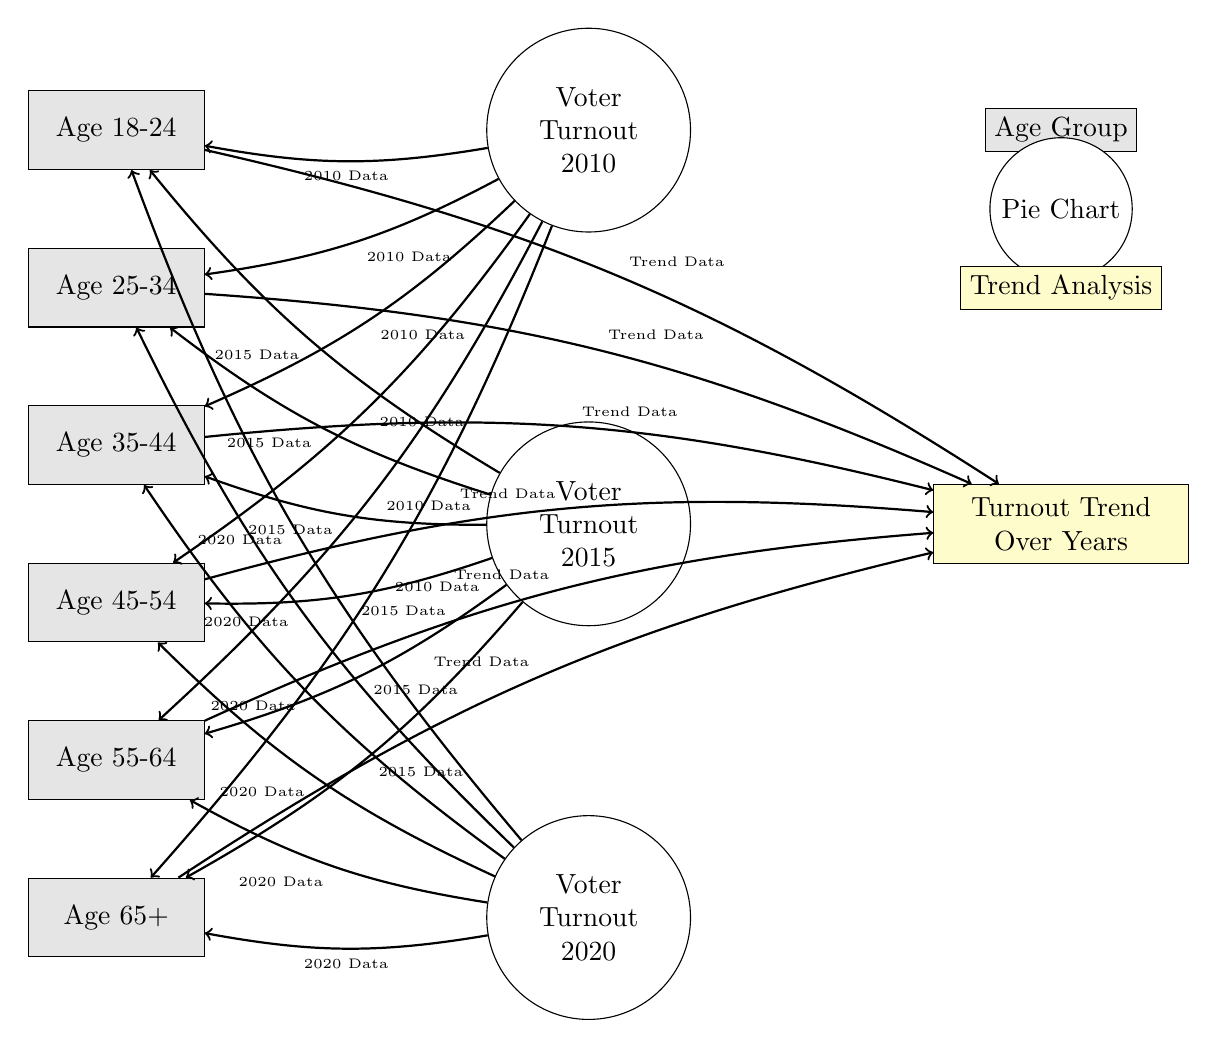What are the age groups represented in the diagram? The age groups listed in the diagram, visible in the nodes on the left, are: Age 18-24, Age 25-34, Age 35-44, Age 45-54, Age 55-64, and Age 65+.
Answer: Age 18-24, Age 25-34, Age 35-44, Age 45-54, Age 55-64, Age 65+ How many pie charts are included in the visualization? The diagram includes three pie charts, representing voter turnout for the years 2010, 2015, and 2020. This can be counted from the three pie chart nodes located on the right.
Answer: Three Which age group is connected to the trend analysis node? All age groups are connected to the trend analysis node through arrows indicating trend data flow, as seen from the connections in the diagram.
Answer: All age groups What type of analysis is depicted in the yellow rectangle? The yellow rectangle signifies trend analysis, as labeled in the diagram. It specifically focuses on the turnout trend over the years.
Answer: Turnout Trend Over Years Which year shows the latest voter turnout information in the pie charts? The pie chart labeled "Voter Turnout 2020" represents the most recent data, as 2020 is the highest year listed among the pie charts.
Answer: 2020 How does the trend analysis relate to the pie charts for different years? The trend analysis node illustrates how attendance behaviors change over years, and each pie chart provides specific turnout data for their respective years. This connection indicates that the trend is influenced by the data presented in each pie chart.
Answer: Attendance behaviors over years Which age group has the lowest likelihood of voting, based on visual reading of the pie charts? Although specific turnout percentages are not provided in the diagram, visual interpretation might suggest the age group with the smallest pie chart segment exhibits the lowest likelihood of voting. This relationship would need to be interpreted from the visual size of the pie segments.
Answer: Interpretation needed from visual size What do the arrows in the diagram signify? The arrows indicate a relationship between age groups, pie charts, and the trend analysis. They show how data flows from the pie charts specific to each year to the respective age group and how those age groups relate to the overall trend analysis over time.
Answer: Data relationships 